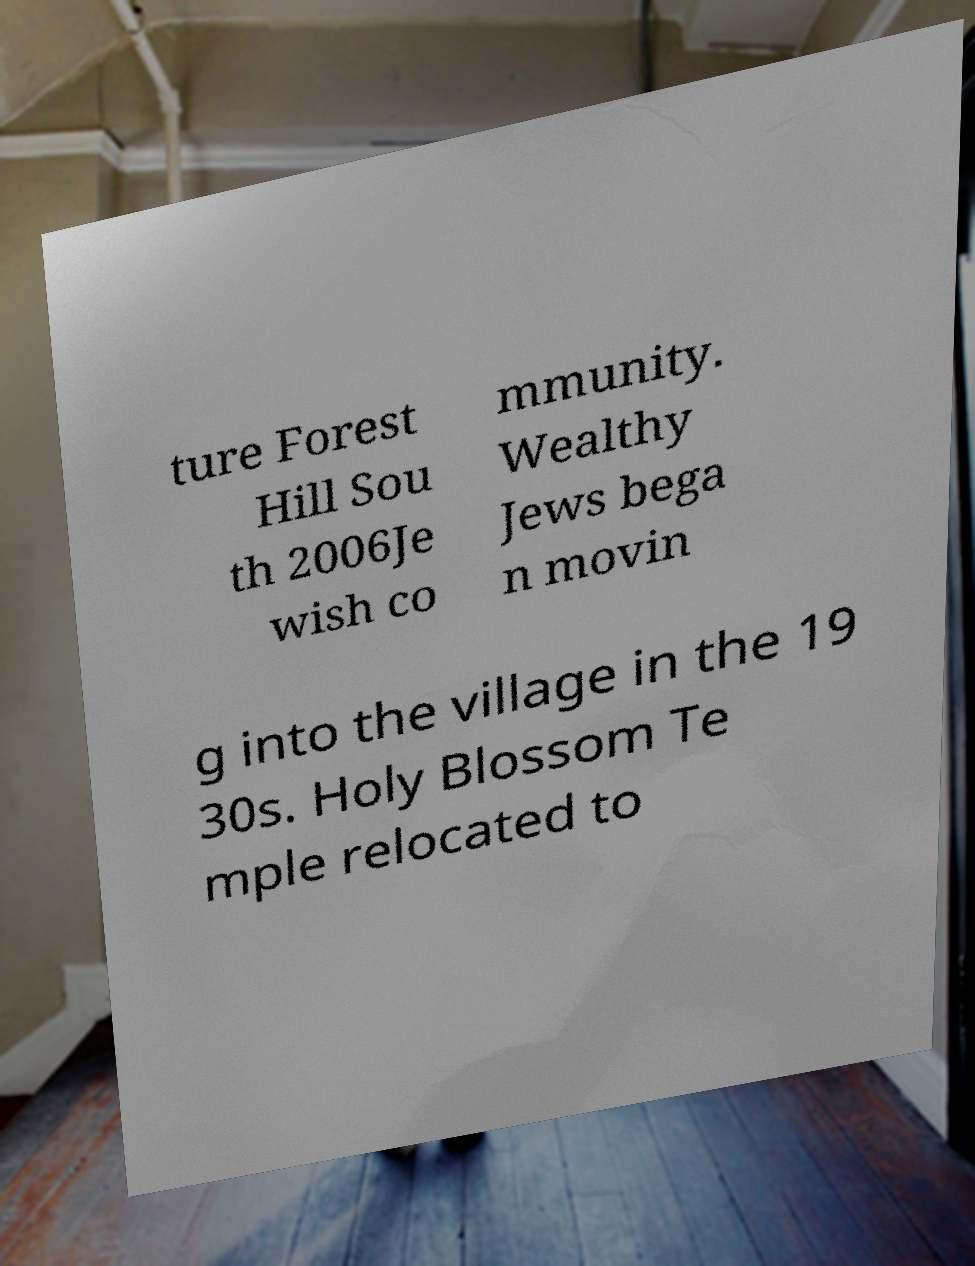What messages or text are displayed in this image? I need them in a readable, typed format. ture Forest Hill Sou th 2006Je wish co mmunity. Wealthy Jews bega n movin g into the village in the 19 30s. Holy Blossom Te mple relocated to 